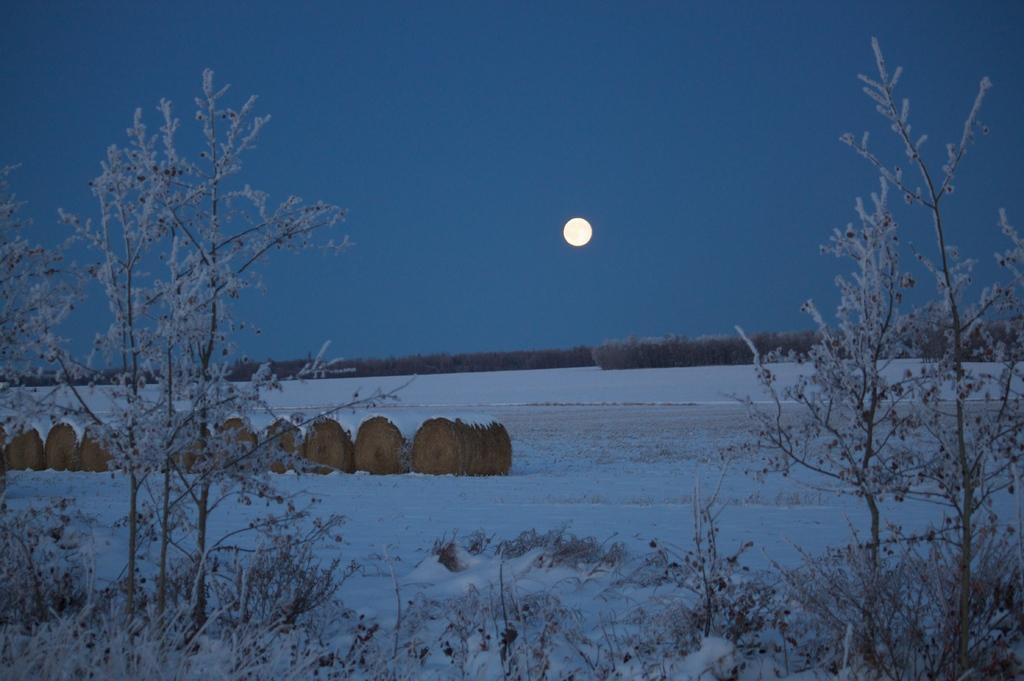How would you summarize this image in a sentence or two? In the picture I can see trees, the snow, plants and some other objects on the ground. In the background I can see the moon and the sky. 